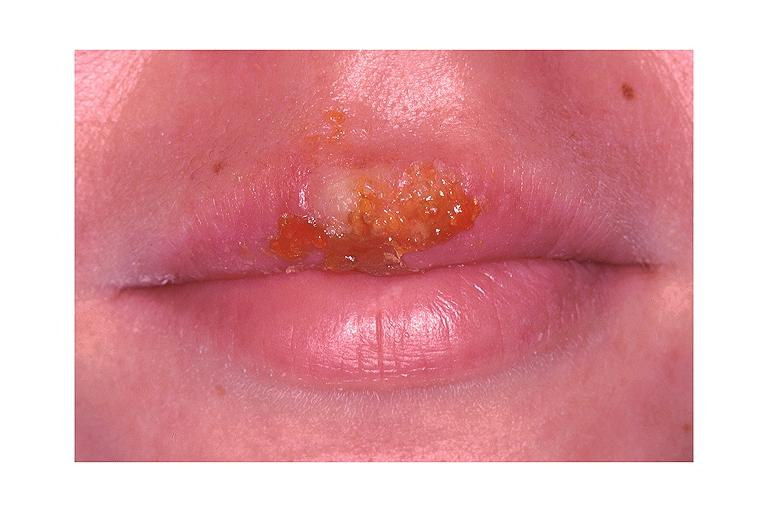what does this image show?
Answer the question using a single word or phrase. Recurrent herpes labialis 